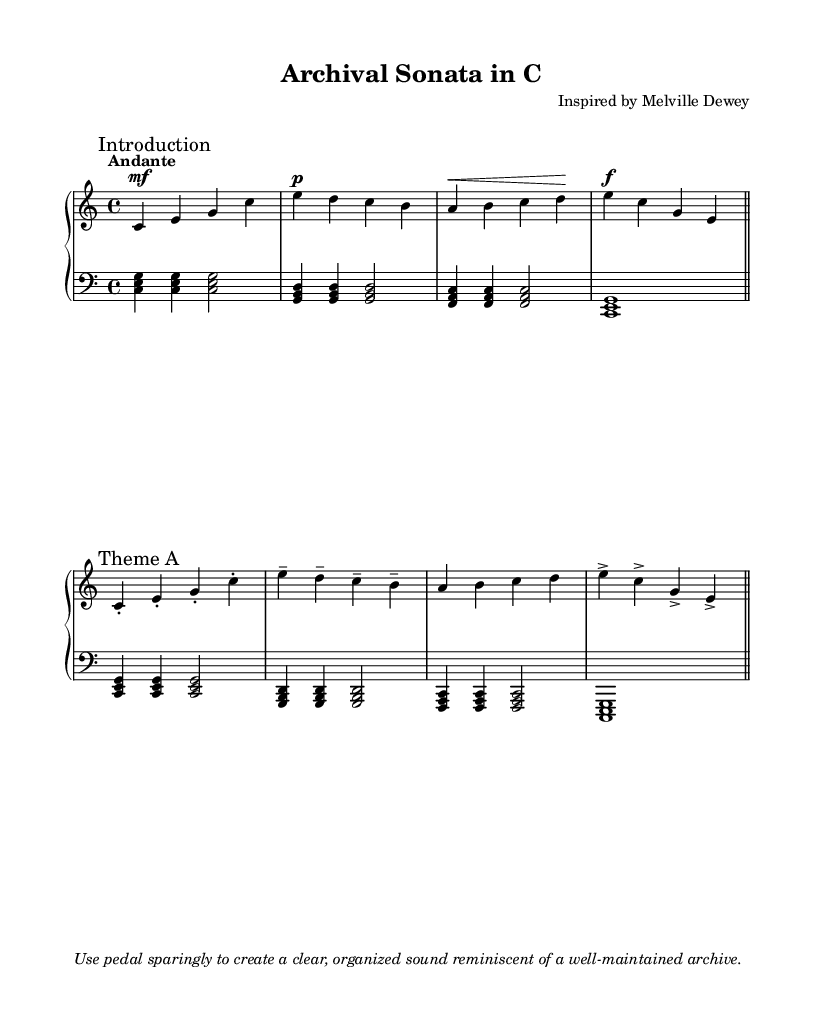What is the key signature of this music? The key signature is indicated at the beginning of the staff as C major, which has no sharps or flats.
Answer: C major What is the time signature of this music? The time signature is shown after the key signature, indicating how many beats are in each measure. It is notated as 4/4, meaning there are four beats per measure.
Answer: 4/4 What is the tempo marking for this piece? The tempo is indicated above the first measure with the word "Andante," which describes a moderately slow pace in music.
Answer: Andante How many measures does the introduction section have? The introduction section contains four measures, as counted visibly from the start until the first barline indicating the end of that section.
Answer: 4 What is the dynamic marking for the Theme A section? The dynamic marking in the Theme A section shows a decrease in loudness (piano) for the second group of notes, indicating softer playing, followed by a loud passage marked as forte.
Answer: piano and forte How is the pedal usage suggested in this composition? In the markup section at the end, it advises using the pedal sparingly to maintain clarity, which aligns well with the clean and organized theme of archiving.
Answer: Sparingly 